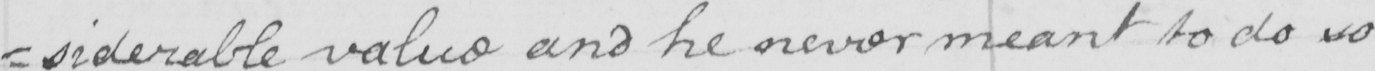What does this handwritten line say? : siderable value and he never meant to do so 